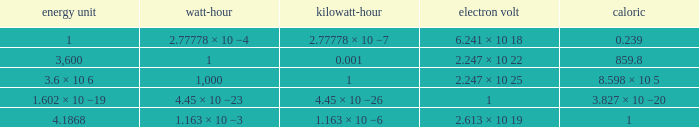How many electronvolts is 3,600 joules? 2.247 × 10 22. 